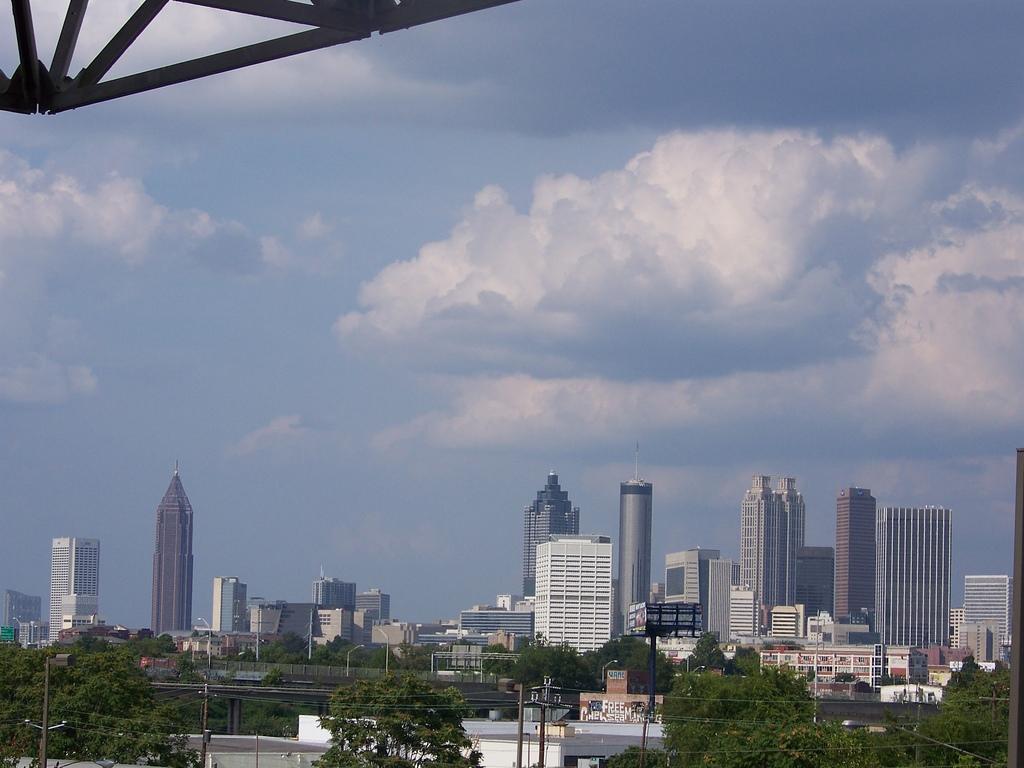Can you describe this image briefly? At the bottom of the picture there are skyscrapers, building, trees, bridge, light, poles, cables and other objects. In the center of the picture we can see clouds. At the top there is an iron object. 